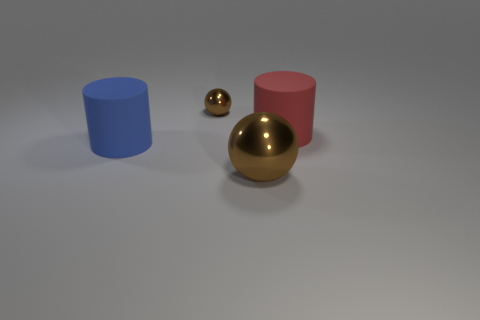There is a large rubber object on the left side of the matte cylinder that is to the right of the tiny brown object; what is its shape?
Keep it short and to the point. Cylinder. What number of objects are brown shiny objects in front of the tiny brown shiny thing or balls that are right of the small brown thing?
Offer a very short reply. 1. The thing that is made of the same material as the blue cylinder is what shape?
Give a very brief answer. Cylinder. Is there anything else of the same color as the large shiny ball?
Your response must be concise. Yes. There is a red object that is the same shape as the blue matte thing; what is its material?
Give a very brief answer. Rubber. How many other things are there of the same size as the red rubber thing?
Provide a short and direct response. 2. What is the red cylinder made of?
Offer a very short reply. Rubber. Are there more big matte cylinders in front of the large red matte cylinder than purple blocks?
Your answer should be compact. Yes. Are any green matte cylinders visible?
Provide a short and direct response. No. How many other things are there of the same shape as the big shiny object?
Your answer should be compact. 1. 